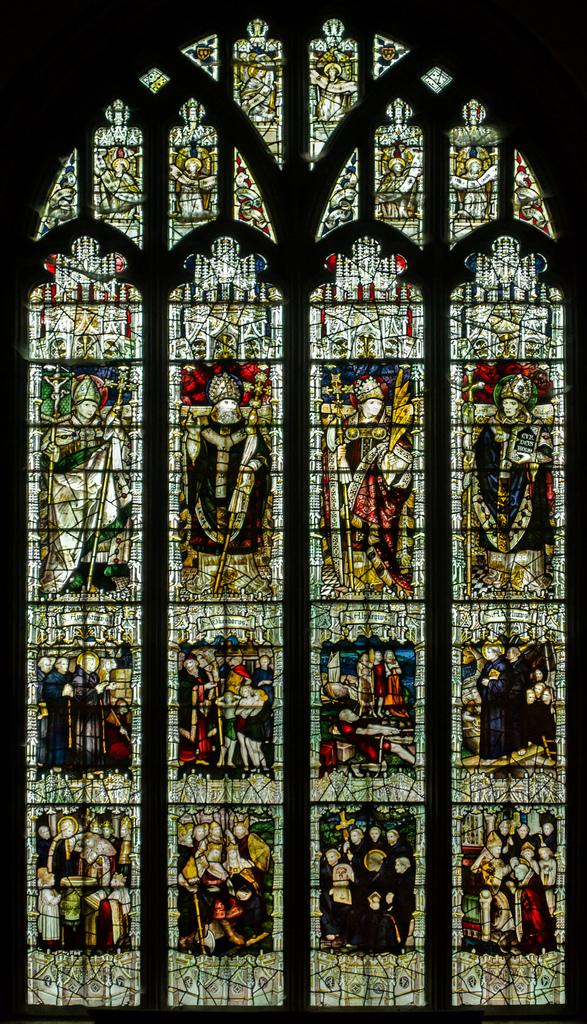What is present in the image that provides a view or access to the outdoors? There is a window in the image. What can be seen on the glass of the window? There are pictures of a group of people on the glass of the window. What type of spark can be seen coming from the suit in the image? There is no suit or spark present in the image; it only features a window with pictures on the glass. 